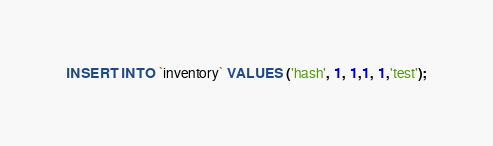<code> <loc_0><loc_0><loc_500><loc_500><_SQL_>INSERT INTO `inventory` VALUES ('hash', 1, 1,1, 1,'test');
</code> 